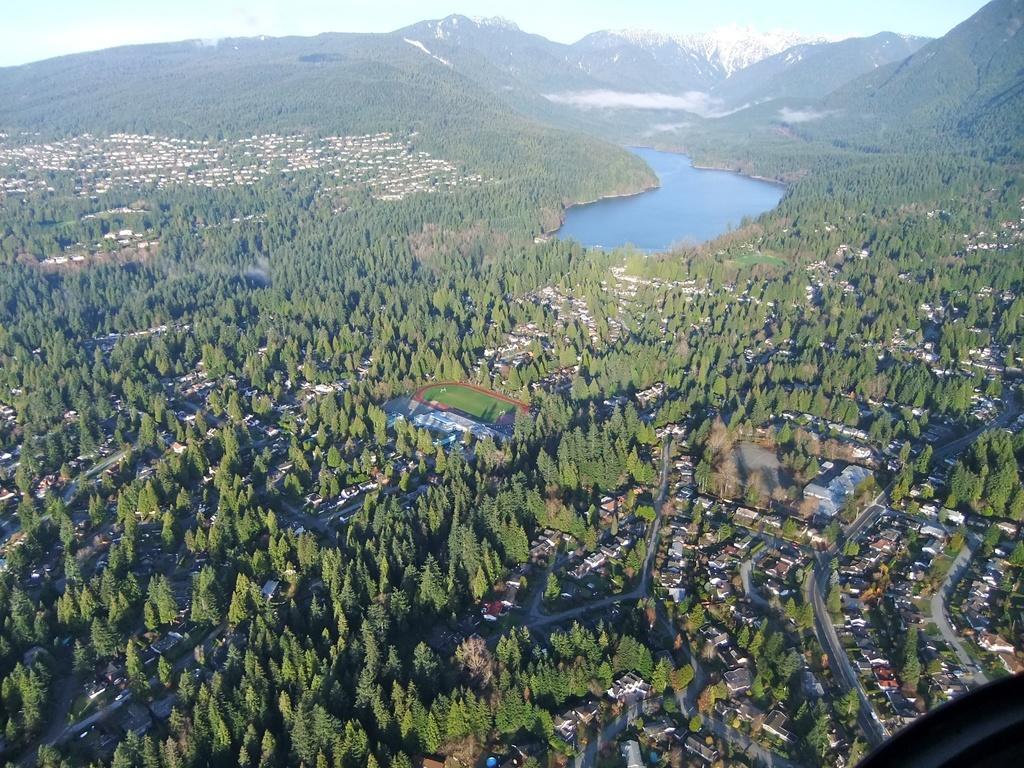In one or two sentences, can you explain what this image depicts? This is an aerial view. In the aerial view we can see buildings, trees, roads, water, hills, mountains and sky. 